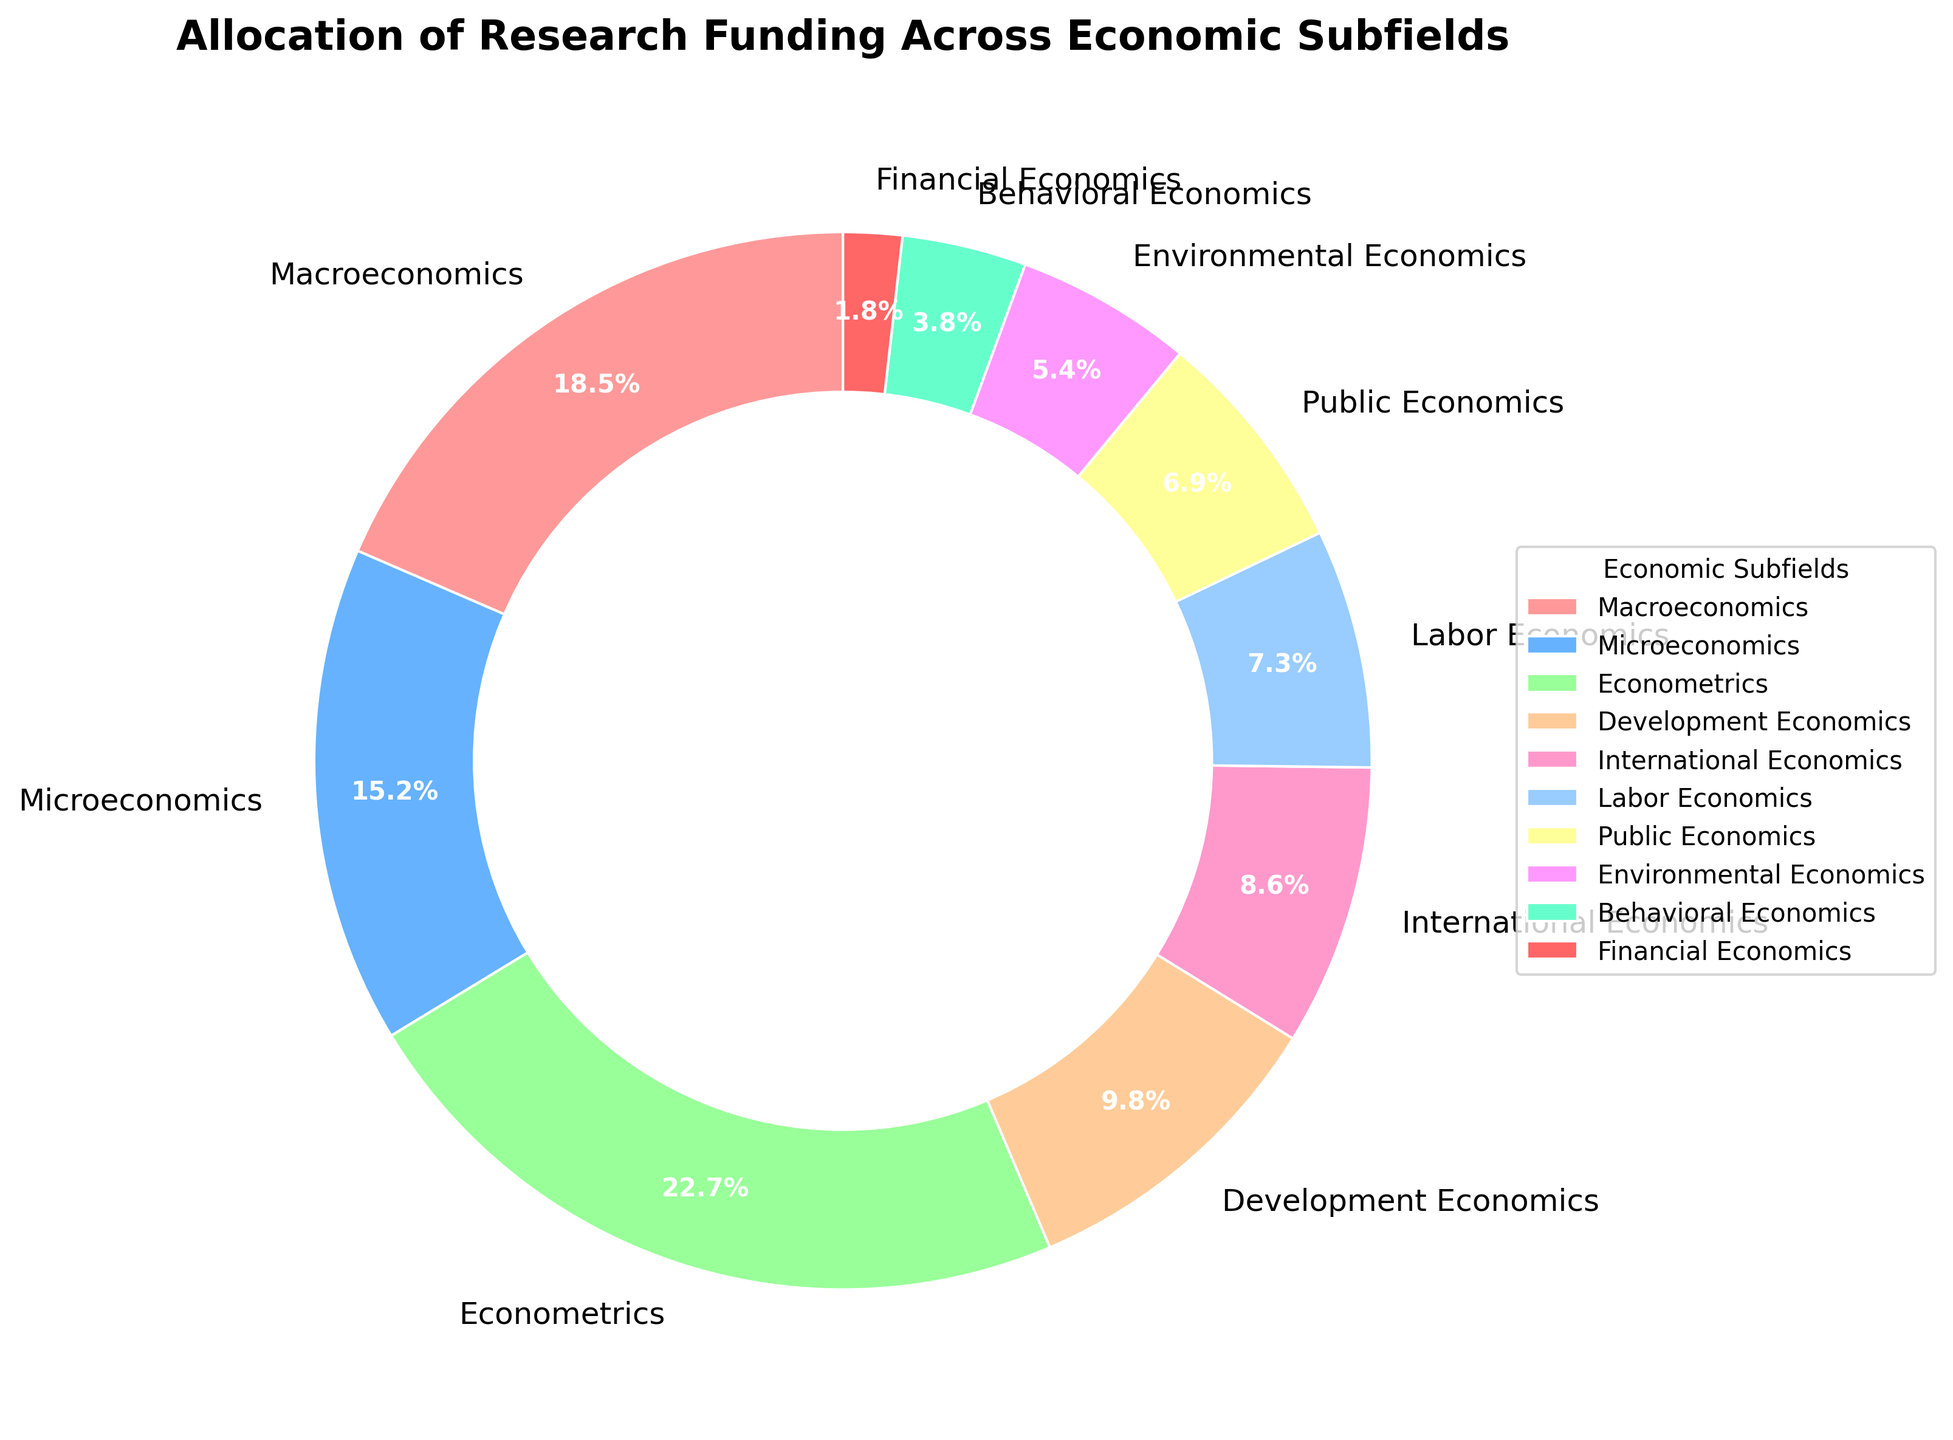Which subfield received the highest funding percentage? To find the subfield with the highest funding, look at the labels and percentages in the pie chart. The highest percentage is 22.7%, which corresponds to Econometrics.
Answer: Econometrics What is the total funding percentage allocated to Macroeconomics, Microeconomics, and Econometrics? Sum the percentages for Macroeconomics (18.5%), Microeconomics (15.2%), and Econometrics (22.7%). The total is 18.5 + 15.2 + 22.7 = 56.4%.
Answer: 56.4% How does the funding for Financial Economics compare to Environmental Economics? Financial Economics has 1.8% funding, while Environmental Economics has 5.4%. Financial Economics receives significantly less funding than Environmental Economics.
Answer: Financial Economics receives less What is the difference in funding percentages between Development Economics and Labor Economics? Subtract the funding percentage of Labor Economics (7.3%) from that of Development Economics (9.8%). The difference is 9.8 - 7.3 = 2.5%.
Answer: 2.5% Which subfields received less than 10% of the funding? Identify all subfields with a percentage less than 10%: Development Economics (9.8%), International Economics (8.6%), Labor Economics (7.3%), Public Economics (6.9%), Environmental Economics (5.4%), Behavioral Economics (3.8%), and Financial Economics (1.8%).
Answer: Development Economics, International Economics, Labor Economics, Public Economics, Environmental Economics, Behavioral Economics, Financial Economics Which subfield has the smallest percentage of funding, and what is that percentage? Look for the smallest percentage in the pie chart, which belongs to Financial Economics with 1.8%.
Answer: Financial Economics, 1.8% What is the combined funding percentage of the three least funded subfields? The three least funded subfields are Financial Economics (1.8%), Behavioral Economics (3.8%), and Environmental Economics (5.4%). The combined percentage is 1.8 + 3.8 + 5.4 = 11%.
Answer: 11% How much more funding does Econometrics receive compared to Public Economics? Subtract the percentage of Public Economics (6.9%) from Econometrics (22.7%). The difference is 22.7 - 6.9 = 15.8%.
Answer: 15.8% What percentage of the total funding is allocated to subfields other than Econometrics? Subtract the funding percentage of Econometrics (22.7%) from the total funding (100%). The remaining funding is 100 - 22.7 = 77.3%.
Answer: 77.3% Which subfield is represented by the blue color in the pie chart? Match the colors from the chart to the subfields. The blue color is used for Microeconomics.
Answer: Microeconomics 